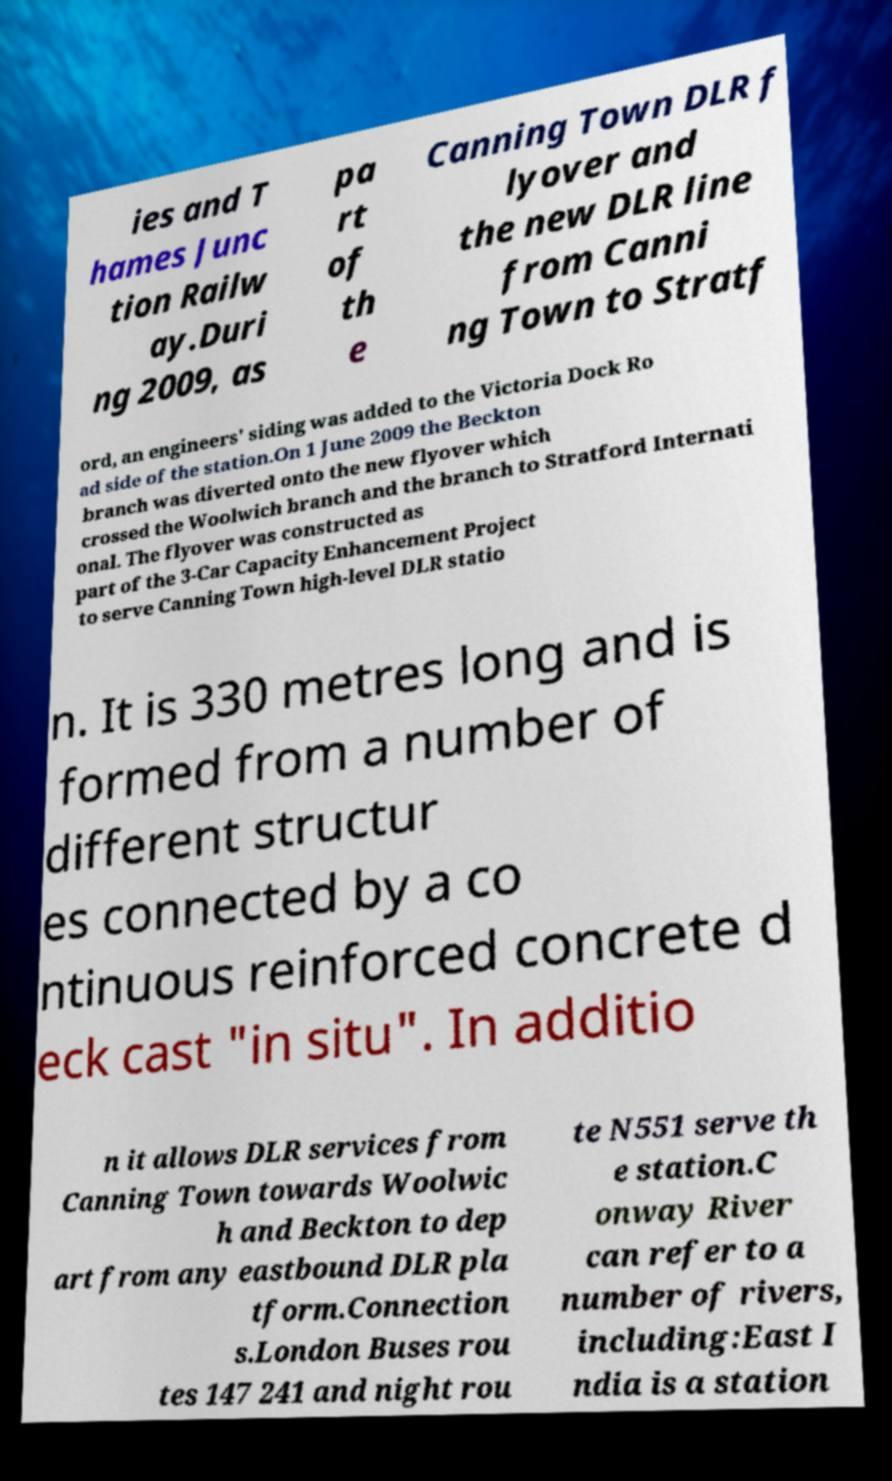Please identify and transcribe the text found in this image. ies and T hames Junc tion Railw ay.Duri ng 2009, as pa rt of th e Canning Town DLR f lyover and the new DLR line from Canni ng Town to Stratf ord, an engineers' siding was added to the Victoria Dock Ro ad side of the station.On 1 June 2009 the Beckton branch was diverted onto the new flyover which crossed the Woolwich branch and the branch to Stratford Internati onal. The flyover was constructed as part of the 3-Car Capacity Enhancement Project to serve Canning Town high-level DLR statio n. It is 330 metres long and is formed from a number of different structur es connected by a co ntinuous reinforced concrete d eck cast "in situ". In additio n it allows DLR services from Canning Town towards Woolwic h and Beckton to dep art from any eastbound DLR pla tform.Connection s.London Buses rou tes 147 241 and night rou te N551 serve th e station.C onway River can refer to a number of rivers, including:East I ndia is a station 